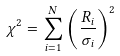<formula> <loc_0><loc_0><loc_500><loc_500>\chi ^ { 2 } = \sum _ { i = 1 } ^ { N } \left ( \frac { R _ { i } } { \sigma _ { i } } \right ) ^ { 2 }</formula> 